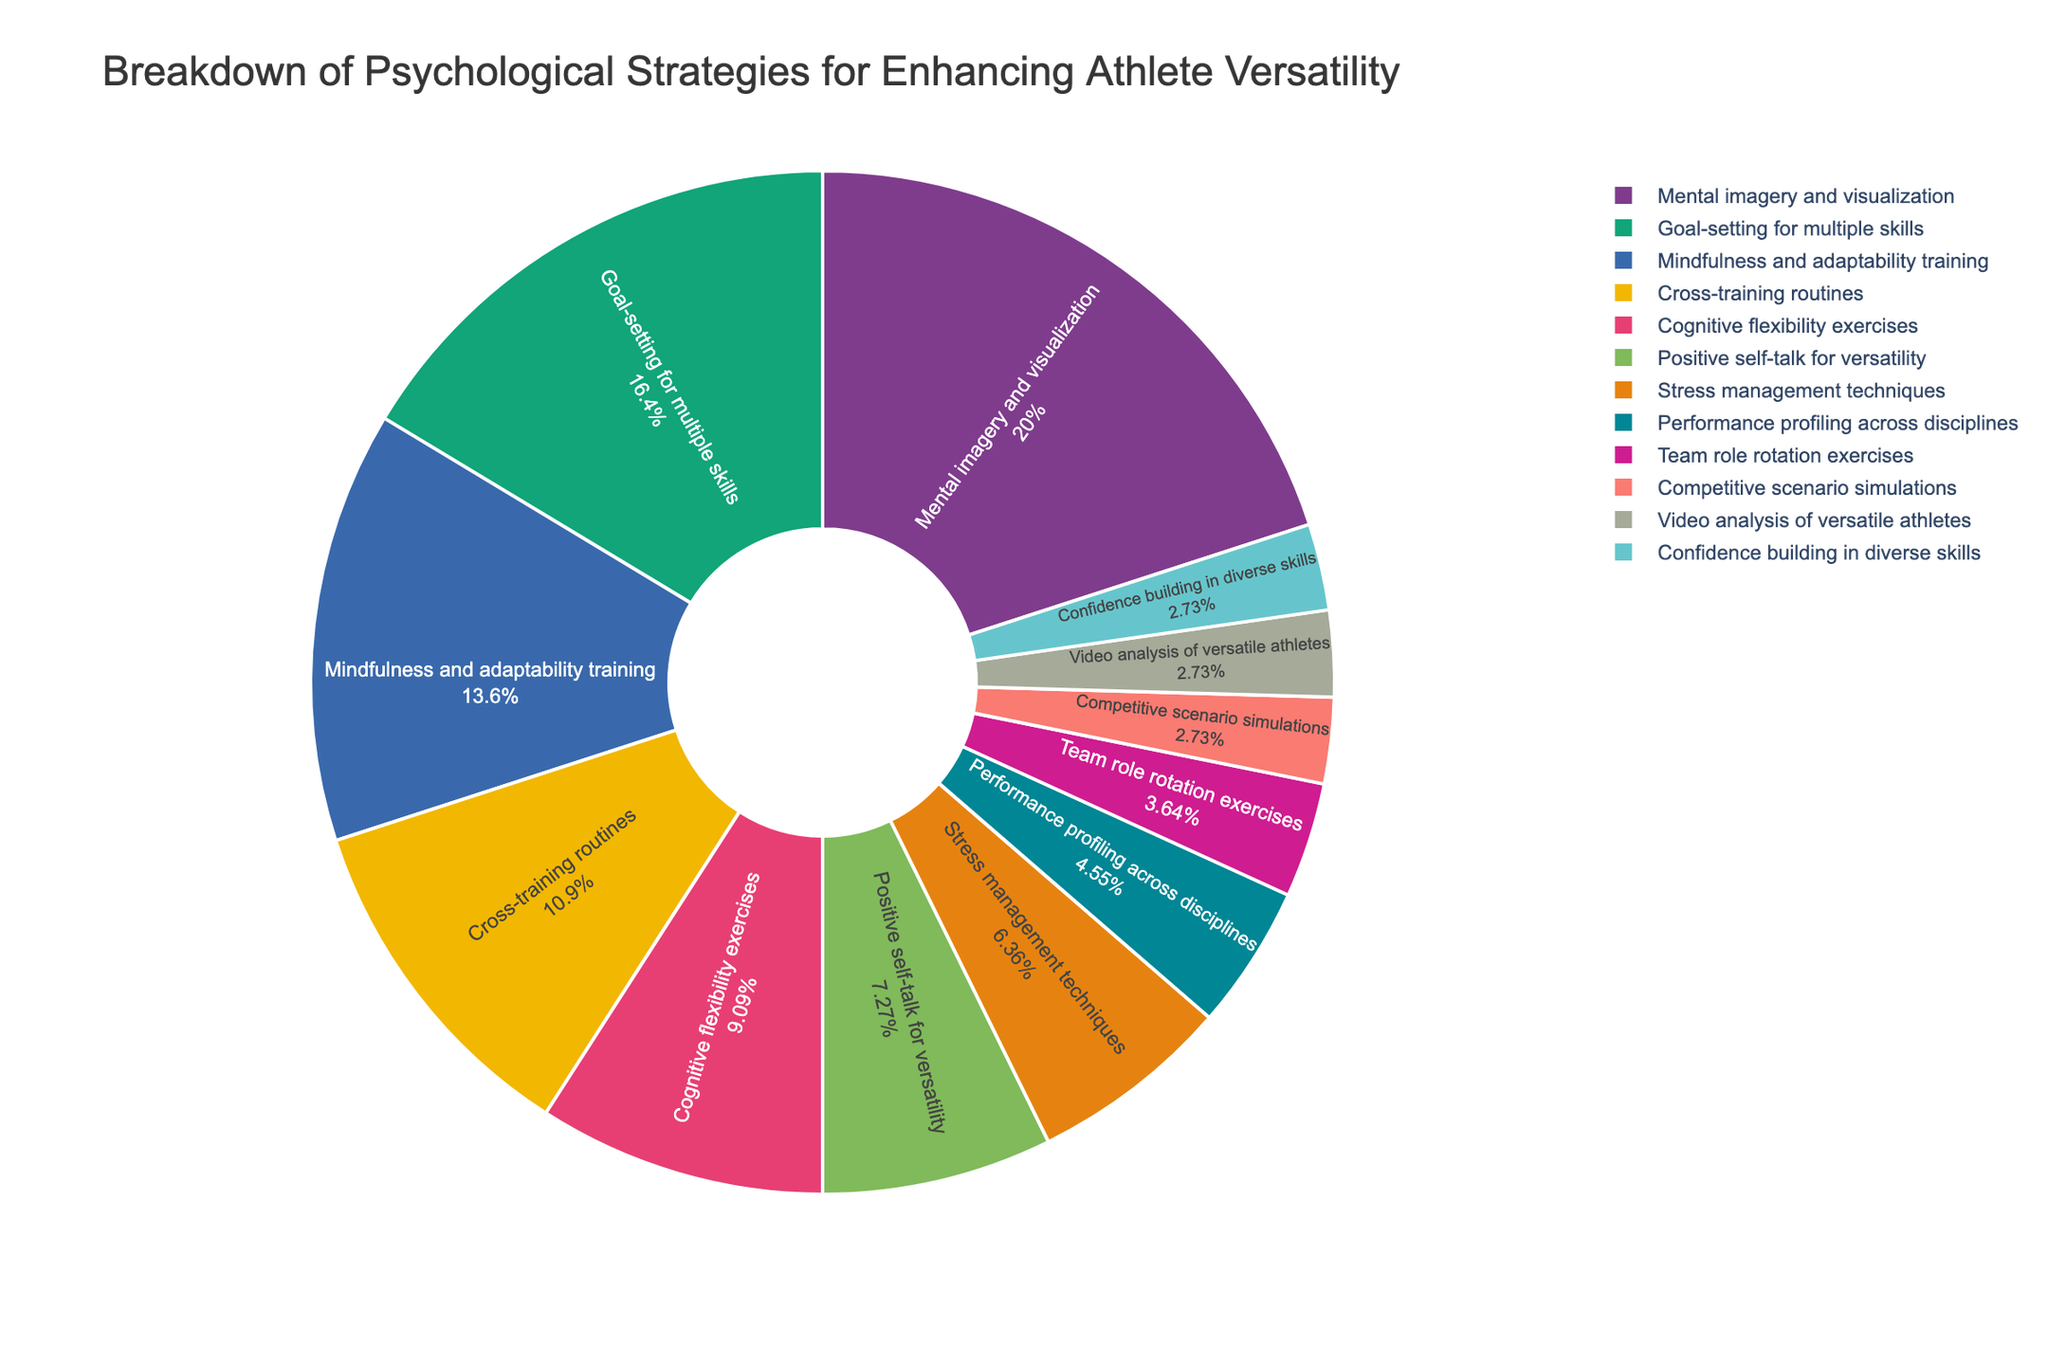what percentage of athletes use performance profiling across disciplines as their psychological strategy? In the pie chart, we can see that the segment labeled "Performance profiling across disciplines" corresponds to a specific percentage of the total pie. By referring to the figure, we notice this segment is associated with the value "5%."
Answer: 5% which two strategies have the same percentage and what is that percentage? By visually inspecting the pie chart, we identify segments with the same numerical value. We can see that "Video analysis of versatile athletes," "Competitive scenario simulations," and "Confidence building in diverse skills" all share the same percentage values.
Answer: 3% is the portion of the chart representing mindfulness and adaptability training larger or smaller than the portion for cross-training routines? The pie chart shows different segments for "Mindfulness and adaptability training" and "Cross-training routines." By visually comparing the sizes of these segments, we can see that the "Mindfulness and adaptability training" segment is larger. This is because it has a value of 15% compared to the 12% of the "Cross-training routines" segment.
Answer: larger what is the total percentage for strategies involving goal-setting and mental imagery? The strategies "Goal-setting for multiple skills" and "Mental imagery and visualization" have percentages of 18% and 22%, respectively. Adding these values will give us the total percentage. 18 + 22 = 40
Answer: 40% list strategies that contribute less than 10% to the total. We need to identify all the strategies whose corresponding segments in the pie chart represent less than 10% of the total. By referring to the chart, we can see that these strategies and their percentages are "Positive self-talk for versatility" (8%), "Stress management techniques" (7%), "Performance profiling across disciplines" (5%), "Team role rotation exercises" (4%), "Competitive scenario simulations" (3%), "Video analysis of versatile athletes" (3%), and "Confidence building in diverse skills" (3%).
Answer: Positive self-talk for versatility, Stress management techniques, Performance profiling across disciplines, Team role rotation exercises, Competitive scenario simulations, Video analysis of versatile athletes, Confidence building in diverse skills by how much does the percentage of mental imagery and visualization exceed the sum of team role rotation exercises and stress management techniques? The percentage for "Mental imagery and visualization" is 22%, while "Team role rotation exercises" and "Stress management techniques" are 4% and 7%, respectively. Adding the latter two values: 4 + 7 = 11, we find the sum is 11%. Subtracting this sum from 22 gives us 22 - 11 = 11.
Answer: 11 what is the combined percentage for the least two used strategies? The pie chart reveals that the least two used strategies are "Competitive scenario simulations," "Video analysis of versatile athletes," and "Confidence building in diverse skills," each at 3%. Adding these percentages together gives us 3 + 3 = 6.
Answer: 6 which strategy has a larger portion: cognitive flexibility exercises or goal-setting for multiple skills, and by how much? Referring to the pie chart, we find that "Goal-setting for multiple skills" holds 18% of the pie, whereas "Cognitive flexibility exercises" occupies 10%. By subtraction, we get 18 - 10 = 8. Therefore, "Goal-setting for multiple skills" is larger by 8%.
Answer: Goal-setting for multiple skills by 8% what is the average percentage of strategies that fall under 5%? Only one strategy falls under 5%, which is "Team role rotation exercises" at 4%. Since this is the only strategy under 5%, the average is simply this value.
Answer: 4 